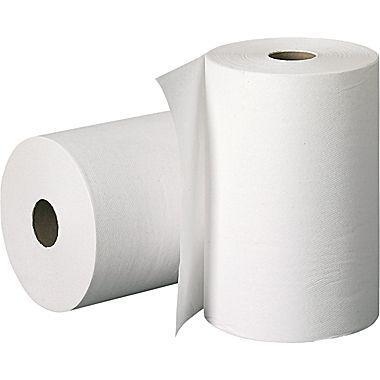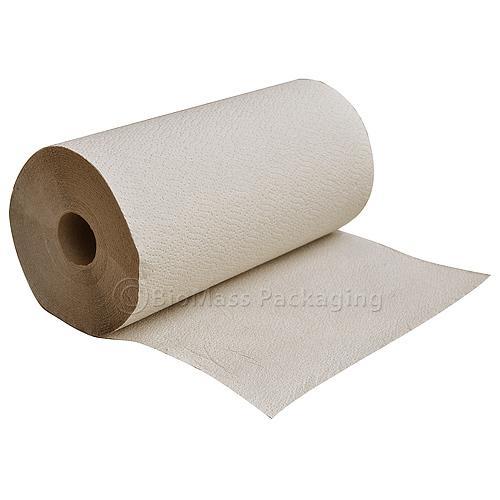The first image is the image on the left, the second image is the image on the right. Given the left and right images, does the statement "One roll of paper towels is brown and at least three are white." hold true? Answer yes or no. No. 